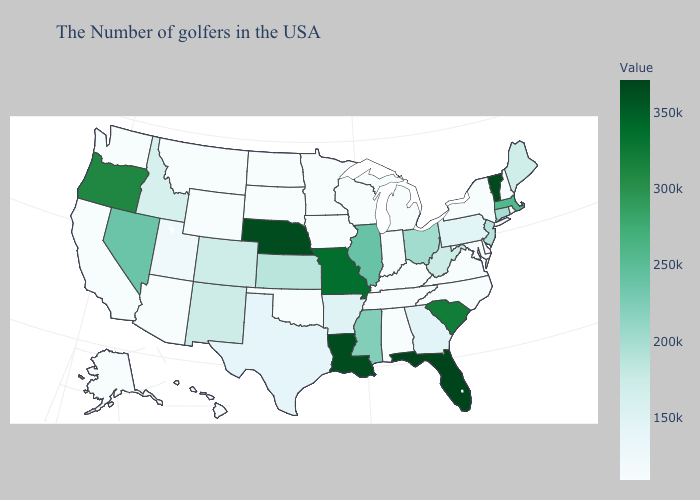Does the map have missing data?
Concise answer only. No. Does Vermont have the highest value in the Northeast?
Answer briefly. Yes. Among the states that border Idaho , which have the highest value?
Give a very brief answer. Oregon. Which states have the highest value in the USA?
Give a very brief answer. Florida. Does Nebraska have the highest value in the USA?
Short answer required. No. Among the states that border Maine , which have the lowest value?
Keep it brief. New Hampshire. Does Montana have a higher value than Colorado?
Keep it brief. No. 